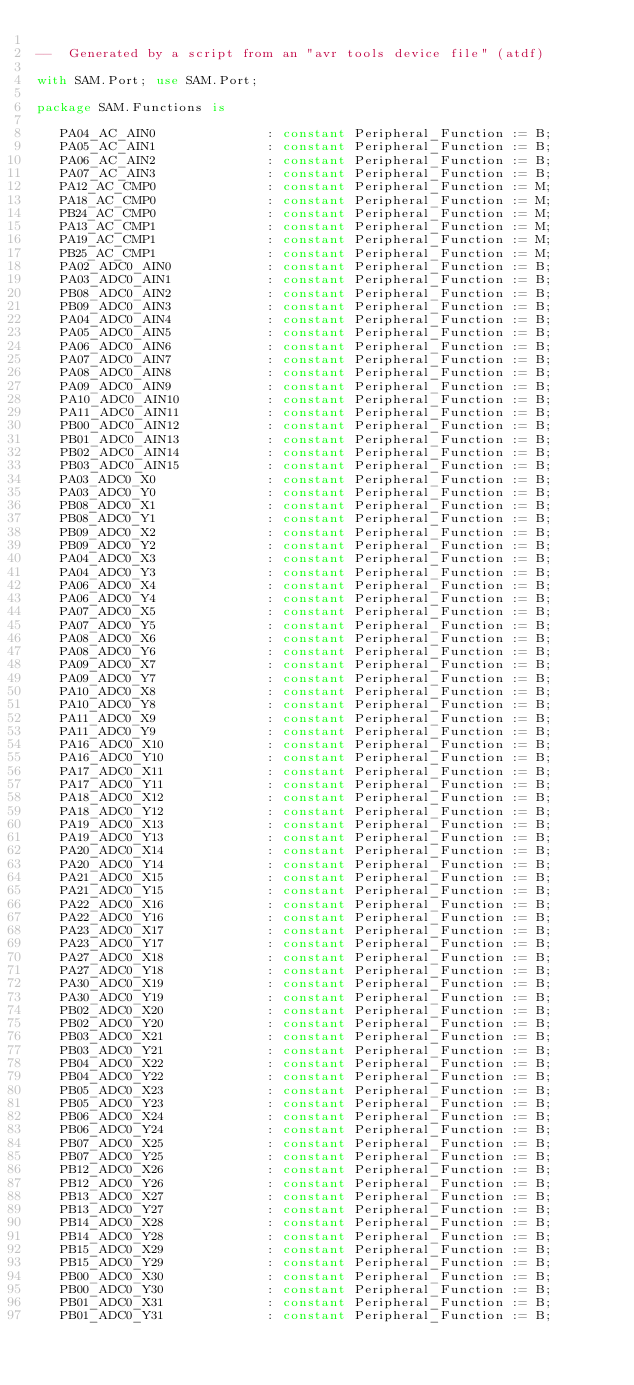<code> <loc_0><loc_0><loc_500><loc_500><_Ada_>
--  Generated by a script from an "avr tools device file" (atdf)

with SAM.Port; use SAM.Port;

package SAM.Functions is

   PA04_AC_AIN0              : constant Peripheral_Function := B;
   PA05_AC_AIN1              : constant Peripheral_Function := B;
   PA06_AC_AIN2              : constant Peripheral_Function := B;
   PA07_AC_AIN3              : constant Peripheral_Function := B;
   PA12_AC_CMP0              : constant Peripheral_Function := M;
   PA18_AC_CMP0              : constant Peripheral_Function := M;
   PB24_AC_CMP0              : constant Peripheral_Function := M;
   PA13_AC_CMP1              : constant Peripheral_Function := M;
   PA19_AC_CMP1              : constant Peripheral_Function := M;
   PB25_AC_CMP1              : constant Peripheral_Function := M;
   PA02_ADC0_AIN0            : constant Peripheral_Function := B;
   PA03_ADC0_AIN1            : constant Peripheral_Function := B;
   PB08_ADC0_AIN2            : constant Peripheral_Function := B;
   PB09_ADC0_AIN3            : constant Peripheral_Function := B;
   PA04_ADC0_AIN4            : constant Peripheral_Function := B;
   PA05_ADC0_AIN5            : constant Peripheral_Function := B;
   PA06_ADC0_AIN6            : constant Peripheral_Function := B;
   PA07_ADC0_AIN7            : constant Peripheral_Function := B;
   PA08_ADC0_AIN8            : constant Peripheral_Function := B;
   PA09_ADC0_AIN9            : constant Peripheral_Function := B;
   PA10_ADC0_AIN10           : constant Peripheral_Function := B;
   PA11_ADC0_AIN11           : constant Peripheral_Function := B;
   PB00_ADC0_AIN12           : constant Peripheral_Function := B;
   PB01_ADC0_AIN13           : constant Peripheral_Function := B;
   PB02_ADC0_AIN14           : constant Peripheral_Function := B;
   PB03_ADC0_AIN15           : constant Peripheral_Function := B;
   PA03_ADC0_X0              : constant Peripheral_Function := B;
   PA03_ADC0_Y0              : constant Peripheral_Function := B;
   PB08_ADC0_X1              : constant Peripheral_Function := B;
   PB08_ADC0_Y1              : constant Peripheral_Function := B;
   PB09_ADC0_X2              : constant Peripheral_Function := B;
   PB09_ADC0_Y2              : constant Peripheral_Function := B;
   PA04_ADC0_X3              : constant Peripheral_Function := B;
   PA04_ADC0_Y3              : constant Peripheral_Function := B;
   PA06_ADC0_X4              : constant Peripheral_Function := B;
   PA06_ADC0_Y4              : constant Peripheral_Function := B;
   PA07_ADC0_X5              : constant Peripheral_Function := B;
   PA07_ADC0_Y5              : constant Peripheral_Function := B;
   PA08_ADC0_X6              : constant Peripheral_Function := B;
   PA08_ADC0_Y6              : constant Peripheral_Function := B;
   PA09_ADC0_X7              : constant Peripheral_Function := B;
   PA09_ADC0_Y7              : constant Peripheral_Function := B;
   PA10_ADC0_X8              : constant Peripheral_Function := B;
   PA10_ADC0_Y8              : constant Peripheral_Function := B;
   PA11_ADC0_X9              : constant Peripheral_Function := B;
   PA11_ADC0_Y9              : constant Peripheral_Function := B;
   PA16_ADC0_X10             : constant Peripheral_Function := B;
   PA16_ADC0_Y10             : constant Peripheral_Function := B;
   PA17_ADC0_X11             : constant Peripheral_Function := B;
   PA17_ADC0_Y11             : constant Peripheral_Function := B;
   PA18_ADC0_X12             : constant Peripheral_Function := B;
   PA18_ADC0_Y12             : constant Peripheral_Function := B;
   PA19_ADC0_X13             : constant Peripheral_Function := B;
   PA19_ADC0_Y13             : constant Peripheral_Function := B;
   PA20_ADC0_X14             : constant Peripheral_Function := B;
   PA20_ADC0_Y14             : constant Peripheral_Function := B;
   PA21_ADC0_X15             : constant Peripheral_Function := B;
   PA21_ADC0_Y15             : constant Peripheral_Function := B;
   PA22_ADC0_X16             : constant Peripheral_Function := B;
   PA22_ADC0_Y16             : constant Peripheral_Function := B;
   PA23_ADC0_X17             : constant Peripheral_Function := B;
   PA23_ADC0_Y17             : constant Peripheral_Function := B;
   PA27_ADC0_X18             : constant Peripheral_Function := B;
   PA27_ADC0_Y18             : constant Peripheral_Function := B;
   PA30_ADC0_X19             : constant Peripheral_Function := B;
   PA30_ADC0_Y19             : constant Peripheral_Function := B;
   PB02_ADC0_X20             : constant Peripheral_Function := B;
   PB02_ADC0_Y20             : constant Peripheral_Function := B;
   PB03_ADC0_X21             : constant Peripheral_Function := B;
   PB03_ADC0_Y21             : constant Peripheral_Function := B;
   PB04_ADC0_X22             : constant Peripheral_Function := B;
   PB04_ADC0_Y22             : constant Peripheral_Function := B;
   PB05_ADC0_X23             : constant Peripheral_Function := B;
   PB05_ADC0_Y23             : constant Peripheral_Function := B;
   PB06_ADC0_X24             : constant Peripheral_Function := B;
   PB06_ADC0_Y24             : constant Peripheral_Function := B;
   PB07_ADC0_X25             : constant Peripheral_Function := B;
   PB07_ADC0_Y25             : constant Peripheral_Function := B;
   PB12_ADC0_X26             : constant Peripheral_Function := B;
   PB12_ADC0_Y26             : constant Peripheral_Function := B;
   PB13_ADC0_X27             : constant Peripheral_Function := B;
   PB13_ADC0_Y27             : constant Peripheral_Function := B;
   PB14_ADC0_X28             : constant Peripheral_Function := B;
   PB14_ADC0_Y28             : constant Peripheral_Function := B;
   PB15_ADC0_X29             : constant Peripheral_Function := B;
   PB15_ADC0_Y29             : constant Peripheral_Function := B;
   PB00_ADC0_X30             : constant Peripheral_Function := B;
   PB00_ADC0_Y30             : constant Peripheral_Function := B;
   PB01_ADC0_X31             : constant Peripheral_Function := B;
   PB01_ADC0_Y31             : constant Peripheral_Function := B;</code> 